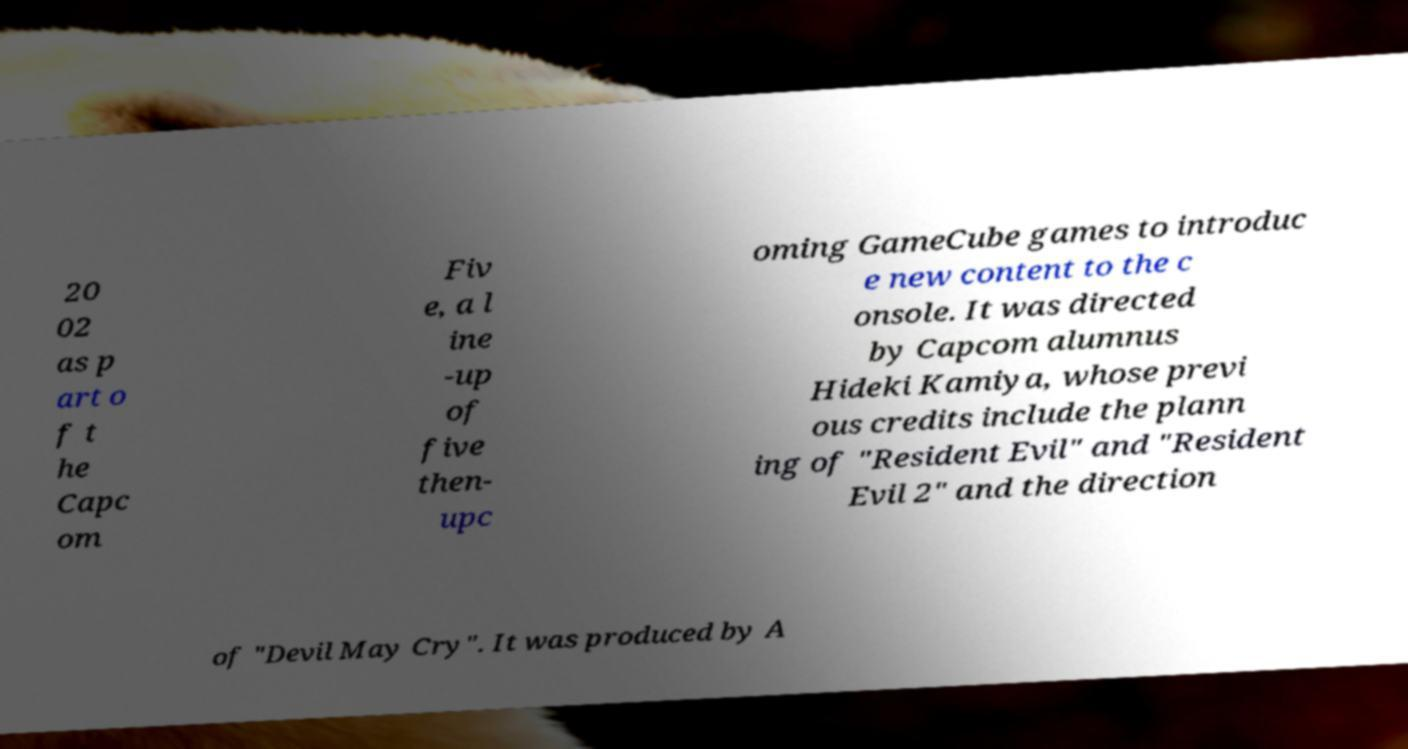I need the written content from this picture converted into text. Can you do that? 20 02 as p art o f t he Capc om Fiv e, a l ine -up of five then- upc oming GameCube games to introduc e new content to the c onsole. It was directed by Capcom alumnus Hideki Kamiya, whose previ ous credits include the plann ing of "Resident Evil" and "Resident Evil 2" and the direction of "Devil May Cry". It was produced by A 